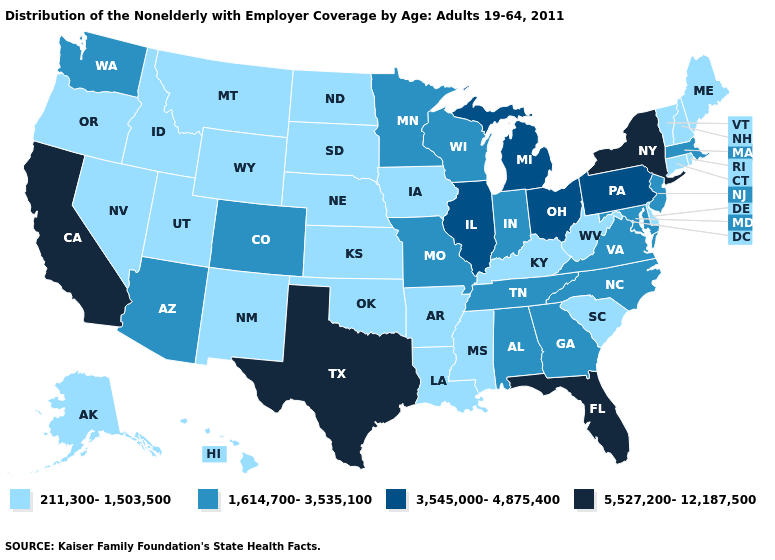Does Vermont have a higher value than Georgia?
Answer briefly. No. What is the value of New Hampshire?
Give a very brief answer. 211,300-1,503,500. What is the value of New Jersey?
Short answer required. 1,614,700-3,535,100. Does Delaware have the lowest value in the South?
Concise answer only. Yes. Name the states that have a value in the range 5,527,200-12,187,500?
Short answer required. California, Florida, New York, Texas. Which states hav the highest value in the MidWest?
Short answer required. Illinois, Michigan, Ohio. Name the states that have a value in the range 3,545,000-4,875,400?
Give a very brief answer. Illinois, Michigan, Ohio, Pennsylvania. What is the highest value in the USA?
Concise answer only. 5,527,200-12,187,500. Is the legend a continuous bar?
Keep it brief. No. Among the states that border New York , which have the lowest value?
Give a very brief answer. Connecticut, Vermont. What is the value of Maine?
Concise answer only. 211,300-1,503,500. Name the states that have a value in the range 211,300-1,503,500?
Quick response, please. Alaska, Arkansas, Connecticut, Delaware, Hawaii, Idaho, Iowa, Kansas, Kentucky, Louisiana, Maine, Mississippi, Montana, Nebraska, Nevada, New Hampshire, New Mexico, North Dakota, Oklahoma, Oregon, Rhode Island, South Carolina, South Dakota, Utah, Vermont, West Virginia, Wyoming. What is the lowest value in states that border South Dakota?
Concise answer only. 211,300-1,503,500. What is the value of Florida?
Concise answer only. 5,527,200-12,187,500. 